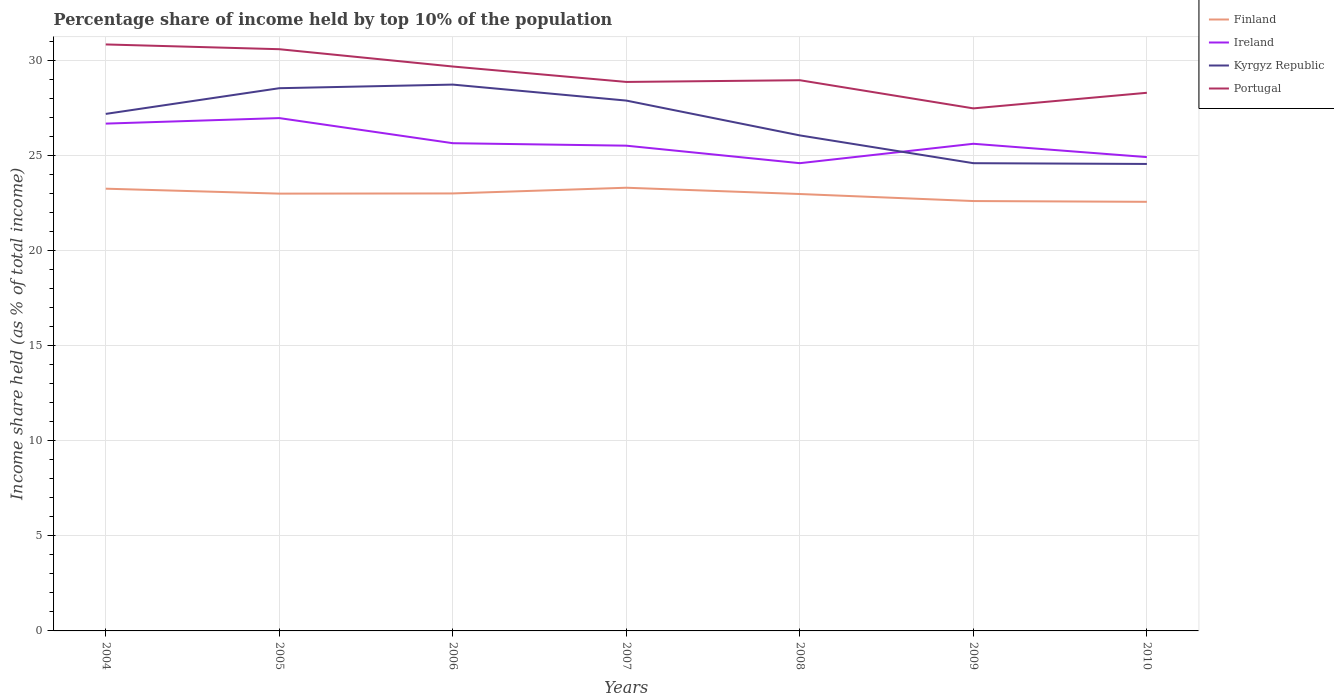Is the number of lines equal to the number of legend labels?
Your response must be concise. Yes. Across all years, what is the maximum percentage share of income held by top 10% of the population in Kyrgyz Republic?
Keep it short and to the point. 24.54. What is the total percentage share of income held by top 10% of the population in Kyrgyz Republic in the graph?
Offer a terse response. 2.63. What is the difference between the highest and the second highest percentage share of income held by top 10% of the population in Finland?
Provide a succinct answer. 0.74. What is the difference between the highest and the lowest percentage share of income held by top 10% of the population in Ireland?
Offer a terse response. 2. Is the percentage share of income held by top 10% of the population in Ireland strictly greater than the percentage share of income held by top 10% of the population in Portugal over the years?
Your response must be concise. Yes. How many lines are there?
Make the answer very short. 4. Are the values on the major ticks of Y-axis written in scientific E-notation?
Ensure brevity in your answer.  No. How are the legend labels stacked?
Give a very brief answer. Vertical. What is the title of the graph?
Your answer should be very brief. Percentage share of income held by top 10% of the population. Does "Cambodia" appear as one of the legend labels in the graph?
Provide a short and direct response. No. What is the label or title of the X-axis?
Ensure brevity in your answer.  Years. What is the label or title of the Y-axis?
Your answer should be very brief. Income share held (as % of total income). What is the Income share held (as % of total income) in Finland in 2004?
Give a very brief answer. 23.24. What is the Income share held (as % of total income) in Ireland in 2004?
Ensure brevity in your answer.  26.66. What is the Income share held (as % of total income) in Kyrgyz Republic in 2004?
Offer a terse response. 27.17. What is the Income share held (as % of total income) of Portugal in 2004?
Your answer should be compact. 30.82. What is the Income share held (as % of total income) of Finland in 2005?
Give a very brief answer. 22.98. What is the Income share held (as % of total income) in Ireland in 2005?
Keep it short and to the point. 26.95. What is the Income share held (as % of total income) in Kyrgyz Republic in 2005?
Keep it short and to the point. 28.52. What is the Income share held (as % of total income) in Portugal in 2005?
Keep it short and to the point. 30.57. What is the Income share held (as % of total income) of Finland in 2006?
Provide a short and direct response. 22.99. What is the Income share held (as % of total income) of Ireland in 2006?
Offer a terse response. 25.63. What is the Income share held (as % of total income) in Kyrgyz Republic in 2006?
Make the answer very short. 28.71. What is the Income share held (as % of total income) of Portugal in 2006?
Provide a succinct answer. 29.66. What is the Income share held (as % of total income) in Finland in 2007?
Provide a succinct answer. 23.29. What is the Income share held (as % of total income) in Ireland in 2007?
Provide a short and direct response. 25.5. What is the Income share held (as % of total income) of Kyrgyz Republic in 2007?
Provide a succinct answer. 27.87. What is the Income share held (as % of total income) in Portugal in 2007?
Your answer should be compact. 28.85. What is the Income share held (as % of total income) in Finland in 2008?
Offer a terse response. 22.96. What is the Income share held (as % of total income) of Ireland in 2008?
Your answer should be compact. 24.58. What is the Income share held (as % of total income) of Kyrgyz Republic in 2008?
Ensure brevity in your answer.  26.04. What is the Income share held (as % of total income) of Portugal in 2008?
Keep it short and to the point. 28.94. What is the Income share held (as % of total income) of Finland in 2009?
Make the answer very short. 22.59. What is the Income share held (as % of total income) in Ireland in 2009?
Keep it short and to the point. 25.6. What is the Income share held (as % of total income) of Kyrgyz Republic in 2009?
Make the answer very short. 24.58. What is the Income share held (as % of total income) in Portugal in 2009?
Ensure brevity in your answer.  27.46. What is the Income share held (as % of total income) of Finland in 2010?
Your answer should be very brief. 22.55. What is the Income share held (as % of total income) in Ireland in 2010?
Make the answer very short. 24.9. What is the Income share held (as % of total income) of Kyrgyz Republic in 2010?
Your answer should be very brief. 24.54. What is the Income share held (as % of total income) of Portugal in 2010?
Ensure brevity in your answer.  28.28. Across all years, what is the maximum Income share held (as % of total income) of Finland?
Provide a short and direct response. 23.29. Across all years, what is the maximum Income share held (as % of total income) in Ireland?
Offer a terse response. 26.95. Across all years, what is the maximum Income share held (as % of total income) in Kyrgyz Republic?
Your response must be concise. 28.71. Across all years, what is the maximum Income share held (as % of total income) of Portugal?
Your answer should be very brief. 30.82. Across all years, what is the minimum Income share held (as % of total income) in Finland?
Provide a succinct answer. 22.55. Across all years, what is the minimum Income share held (as % of total income) of Ireland?
Ensure brevity in your answer.  24.58. Across all years, what is the minimum Income share held (as % of total income) in Kyrgyz Republic?
Give a very brief answer. 24.54. Across all years, what is the minimum Income share held (as % of total income) in Portugal?
Your response must be concise. 27.46. What is the total Income share held (as % of total income) of Finland in the graph?
Ensure brevity in your answer.  160.6. What is the total Income share held (as % of total income) of Ireland in the graph?
Your answer should be compact. 179.82. What is the total Income share held (as % of total income) of Kyrgyz Republic in the graph?
Your response must be concise. 187.43. What is the total Income share held (as % of total income) in Portugal in the graph?
Ensure brevity in your answer.  204.58. What is the difference between the Income share held (as % of total income) in Finland in 2004 and that in 2005?
Provide a short and direct response. 0.26. What is the difference between the Income share held (as % of total income) of Ireland in 2004 and that in 2005?
Your response must be concise. -0.29. What is the difference between the Income share held (as % of total income) in Kyrgyz Republic in 2004 and that in 2005?
Give a very brief answer. -1.35. What is the difference between the Income share held (as % of total income) in Finland in 2004 and that in 2006?
Your response must be concise. 0.25. What is the difference between the Income share held (as % of total income) of Ireland in 2004 and that in 2006?
Provide a short and direct response. 1.03. What is the difference between the Income share held (as % of total income) of Kyrgyz Republic in 2004 and that in 2006?
Your answer should be compact. -1.54. What is the difference between the Income share held (as % of total income) of Portugal in 2004 and that in 2006?
Offer a very short reply. 1.16. What is the difference between the Income share held (as % of total income) of Ireland in 2004 and that in 2007?
Ensure brevity in your answer.  1.16. What is the difference between the Income share held (as % of total income) in Portugal in 2004 and that in 2007?
Give a very brief answer. 1.97. What is the difference between the Income share held (as % of total income) of Finland in 2004 and that in 2008?
Make the answer very short. 0.28. What is the difference between the Income share held (as % of total income) of Ireland in 2004 and that in 2008?
Keep it short and to the point. 2.08. What is the difference between the Income share held (as % of total income) of Kyrgyz Republic in 2004 and that in 2008?
Your answer should be compact. 1.13. What is the difference between the Income share held (as % of total income) of Portugal in 2004 and that in 2008?
Ensure brevity in your answer.  1.88. What is the difference between the Income share held (as % of total income) of Finland in 2004 and that in 2009?
Provide a short and direct response. 0.65. What is the difference between the Income share held (as % of total income) in Ireland in 2004 and that in 2009?
Give a very brief answer. 1.06. What is the difference between the Income share held (as % of total income) of Kyrgyz Republic in 2004 and that in 2009?
Offer a terse response. 2.59. What is the difference between the Income share held (as % of total income) in Portugal in 2004 and that in 2009?
Give a very brief answer. 3.36. What is the difference between the Income share held (as % of total income) of Finland in 2004 and that in 2010?
Make the answer very short. 0.69. What is the difference between the Income share held (as % of total income) of Ireland in 2004 and that in 2010?
Make the answer very short. 1.76. What is the difference between the Income share held (as % of total income) in Kyrgyz Republic in 2004 and that in 2010?
Your response must be concise. 2.63. What is the difference between the Income share held (as % of total income) of Portugal in 2004 and that in 2010?
Provide a short and direct response. 2.54. What is the difference between the Income share held (as % of total income) of Finland in 2005 and that in 2006?
Make the answer very short. -0.01. What is the difference between the Income share held (as % of total income) in Ireland in 2005 and that in 2006?
Offer a terse response. 1.32. What is the difference between the Income share held (as % of total income) in Kyrgyz Republic in 2005 and that in 2006?
Your response must be concise. -0.19. What is the difference between the Income share held (as % of total income) in Portugal in 2005 and that in 2006?
Your response must be concise. 0.91. What is the difference between the Income share held (as % of total income) of Finland in 2005 and that in 2007?
Offer a very short reply. -0.31. What is the difference between the Income share held (as % of total income) in Ireland in 2005 and that in 2007?
Make the answer very short. 1.45. What is the difference between the Income share held (as % of total income) in Kyrgyz Republic in 2005 and that in 2007?
Give a very brief answer. 0.65. What is the difference between the Income share held (as % of total income) in Portugal in 2005 and that in 2007?
Offer a terse response. 1.72. What is the difference between the Income share held (as % of total income) in Ireland in 2005 and that in 2008?
Your answer should be compact. 2.37. What is the difference between the Income share held (as % of total income) in Kyrgyz Republic in 2005 and that in 2008?
Offer a terse response. 2.48. What is the difference between the Income share held (as % of total income) in Portugal in 2005 and that in 2008?
Offer a terse response. 1.63. What is the difference between the Income share held (as % of total income) in Finland in 2005 and that in 2009?
Make the answer very short. 0.39. What is the difference between the Income share held (as % of total income) in Ireland in 2005 and that in 2009?
Ensure brevity in your answer.  1.35. What is the difference between the Income share held (as % of total income) of Kyrgyz Republic in 2005 and that in 2009?
Give a very brief answer. 3.94. What is the difference between the Income share held (as % of total income) of Portugal in 2005 and that in 2009?
Keep it short and to the point. 3.11. What is the difference between the Income share held (as % of total income) of Finland in 2005 and that in 2010?
Keep it short and to the point. 0.43. What is the difference between the Income share held (as % of total income) of Ireland in 2005 and that in 2010?
Offer a terse response. 2.05. What is the difference between the Income share held (as % of total income) in Kyrgyz Republic in 2005 and that in 2010?
Provide a succinct answer. 3.98. What is the difference between the Income share held (as % of total income) in Portugal in 2005 and that in 2010?
Offer a very short reply. 2.29. What is the difference between the Income share held (as % of total income) in Finland in 2006 and that in 2007?
Keep it short and to the point. -0.3. What is the difference between the Income share held (as % of total income) of Ireland in 2006 and that in 2007?
Ensure brevity in your answer.  0.13. What is the difference between the Income share held (as % of total income) of Kyrgyz Republic in 2006 and that in 2007?
Ensure brevity in your answer.  0.84. What is the difference between the Income share held (as % of total income) in Portugal in 2006 and that in 2007?
Make the answer very short. 0.81. What is the difference between the Income share held (as % of total income) in Finland in 2006 and that in 2008?
Provide a short and direct response. 0.03. What is the difference between the Income share held (as % of total income) in Kyrgyz Republic in 2006 and that in 2008?
Make the answer very short. 2.67. What is the difference between the Income share held (as % of total income) of Portugal in 2006 and that in 2008?
Your response must be concise. 0.72. What is the difference between the Income share held (as % of total income) of Finland in 2006 and that in 2009?
Provide a short and direct response. 0.4. What is the difference between the Income share held (as % of total income) of Kyrgyz Republic in 2006 and that in 2009?
Provide a short and direct response. 4.13. What is the difference between the Income share held (as % of total income) in Finland in 2006 and that in 2010?
Your response must be concise. 0.44. What is the difference between the Income share held (as % of total income) of Ireland in 2006 and that in 2010?
Provide a succinct answer. 0.73. What is the difference between the Income share held (as % of total income) of Kyrgyz Republic in 2006 and that in 2010?
Keep it short and to the point. 4.17. What is the difference between the Income share held (as % of total income) in Portugal in 2006 and that in 2010?
Offer a very short reply. 1.38. What is the difference between the Income share held (as % of total income) of Finland in 2007 and that in 2008?
Give a very brief answer. 0.33. What is the difference between the Income share held (as % of total income) in Ireland in 2007 and that in 2008?
Your answer should be compact. 0.92. What is the difference between the Income share held (as % of total income) of Kyrgyz Republic in 2007 and that in 2008?
Provide a succinct answer. 1.83. What is the difference between the Income share held (as % of total income) of Portugal in 2007 and that in 2008?
Give a very brief answer. -0.09. What is the difference between the Income share held (as % of total income) of Ireland in 2007 and that in 2009?
Offer a very short reply. -0.1. What is the difference between the Income share held (as % of total income) of Kyrgyz Republic in 2007 and that in 2009?
Your answer should be very brief. 3.29. What is the difference between the Income share held (as % of total income) in Portugal in 2007 and that in 2009?
Give a very brief answer. 1.39. What is the difference between the Income share held (as % of total income) in Finland in 2007 and that in 2010?
Your answer should be very brief. 0.74. What is the difference between the Income share held (as % of total income) of Ireland in 2007 and that in 2010?
Provide a succinct answer. 0.6. What is the difference between the Income share held (as % of total income) in Kyrgyz Republic in 2007 and that in 2010?
Give a very brief answer. 3.33. What is the difference between the Income share held (as % of total income) of Portugal in 2007 and that in 2010?
Give a very brief answer. 0.57. What is the difference between the Income share held (as % of total income) of Finland in 2008 and that in 2009?
Offer a terse response. 0.37. What is the difference between the Income share held (as % of total income) in Ireland in 2008 and that in 2009?
Your answer should be compact. -1.02. What is the difference between the Income share held (as % of total income) in Kyrgyz Republic in 2008 and that in 2009?
Your answer should be compact. 1.46. What is the difference between the Income share held (as % of total income) in Portugal in 2008 and that in 2009?
Ensure brevity in your answer.  1.48. What is the difference between the Income share held (as % of total income) of Finland in 2008 and that in 2010?
Make the answer very short. 0.41. What is the difference between the Income share held (as % of total income) of Ireland in 2008 and that in 2010?
Ensure brevity in your answer.  -0.32. What is the difference between the Income share held (as % of total income) in Kyrgyz Republic in 2008 and that in 2010?
Provide a short and direct response. 1.5. What is the difference between the Income share held (as % of total income) in Portugal in 2008 and that in 2010?
Your answer should be compact. 0.66. What is the difference between the Income share held (as % of total income) of Finland in 2009 and that in 2010?
Offer a very short reply. 0.04. What is the difference between the Income share held (as % of total income) of Ireland in 2009 and that in 2010?
Provide a short and direct response. 0.7. What is the difference between the Income share held (as % of total income) of Kyrgyz Republic in 2009 and that in 2010?
Make the answer very short. 0.04. What is the difference between the Income share held (as % of total income) in Portugal in 2009 and that in 2010?
Give a very brief answer. -0.82. What is the difference between the Income share held (as % of total income) of Finland in 2004 and the Income share held (as % of total income) of Ireland in 2005?
Your answer should be very brief. -3.71. What is the difference between the Income share held (as % of total income) in Finland in 2004 and the Income share held (as % of total income) in Kyrgyz Republic in 2005?
Keep it short and to the point. -5.28. What is the difference between the Income share held (as % of total income) in Finland in 2004 and the Income share held (as % of total income) in Portugal in 2005?
Provide a succinct answer. -7.33. What is the difference between the Income share held (as % of total income) in Ireland in 2004 and the Income share held (as % of total income) in Kyrgyz Republic in 2005?
Keep it short and to the point. -1.86. What is the difference between the Income share held (as % of total income) of Ireland in 2004 and the Income share held (as % of total income) of Portugal in 2005?
Your answer should be compact. -3.91. What is the difference between the Income share held (as % of total income) in Kyrgyz Republic in 2004 and the Income share held (as % of total income) in Portugal in 2005?
Your answer should be very brief. -3.4. What is the difference between the Income share held (as % of total income) in Finland in 2004 and the Income share held (as % of total income) in Ireland in 2006?
Offer a very short reply. -2.39. What is the difference between the Income share held (as % of total income) of Finland in 2004 and the Income share held (as % of total income) of Kyrgyz Republic in 2006?
Give a very brief answer. -5.47. What is the difference between the Income share held (as % of total income) in Finland in 2004 and the Income share held (as % of total income) in Portugal in 2006?
Give a very brief answer. -6.42. What is the difference between the Income share held (as % of total income) of Ireland in 2004 and the Income share held (as % of total income) of Kyrgyz Republic in 2006?
Your response must be concise. -2.05. What is the difference between the Income share held (as % of total income) of Ireland in 2004 and the Income share held (as % of total income) of Portugal in 2006?
Keep it short and to the point. -3. What is the difference between the Income share held (as % of total income) in Kyrgyz Republic in 2004 and the Income share held (as % of total income) in Portugal in 2006?
Ensure brevity in your answer.  -2.49. What is the difference between the Income share held (as % of total income) of Finland in 2004 and the Income share held (as % of total income) of Ireland in 2007?
Keep it short and to the point. -2.26. What is the difference between the Income share held (as % of total income) in Finland in 2004 and the Income share held (as % of total income) in Kyrgyz Republic in 2007?
Ensure brevity in your answer.  -4.63. What is the difference between the Income share held (as % of total income) in Finland in 2004 and the Income share held (as % of total income) in Portugal in 2007?
Your answer should be compact. -5.61. What is the difference between the Income share held (as % of total income) of Ireland in 2004 and the Income share held (as % of total income) of Kyrgyz Republic in 2007?
Give a very brief answer. -1.21. What is the difference between the Income share held (as % of total income) of Ireland in 2004 and the Income share held (as % of total income) of Portugal in 2007?
Offer a terse response. -2.19. What is the difference between the Income share held (as % of total income) in Kyrgyz Republic in 2004 and the Income share held (as % of total income) in Portugal in 2007?
Ensure brevity in your answer.  -1.68. What is the difference between the Income share held (as % of total income) in Finland in 2004 and the Income share held (as % of total income) in Ireland in 2008?
Your response must be concise. -1.34. What is the difference between the Income share held (as % of total income) in Finland in 2004 and the Income share held (as % of total income) in Kyrgyz Republic in 2008?
Your answer should be very brief. -2.8. What is the difference between the Income share held (as % of total income) in Finland in 2004 and the Income share held (as % of total income) in Portugal in 2008?
Offer a terse response. -5.7. What is the difference between the Income share held (as % of total income) in Ireland in 2004 and the Income share held (as % of total income) in Kyrgyz Republic in 2008?
Offer a very short reply. 0.62. What is the difference between the Income share held (as % of total income) of Ireland in 2004 and the Income share held (as % of total income) of Portugal in 2008?
Ensure brevity in your answer.  -2.28. What is the difference between the Income share held (as % of total income) of Kyrgyz Republic in 2004 and the Income share held (as % of total income) of Portugal in 2008?
Ensure brevity in your answer.  -1.77. What is the difference between the Income share held (as % of total income) in Finland in 2004 and the Income share held (as % of total income) in Ireland in 2009?
Your answer should be compact. -2.36. What is the difference between the Income share held (as % of total income) of Finland in 2004 and the Income share held (as % of total income) of Kyrgyz Republic in 2009?
Offer a terse response. -1.34. What is the difference between the Income share held (as % of total income) of Finland in 2004 and the Income share held (as % of total income) of Portugal in 2009?
Your response must be concise. -4.22. What is the difference between the Income share held (as % of total income) in Ireland in 2004 and the Income share held (as % of total income) in Kyrgyz Republic in 2009?
Offer a terse response. 2.08. What is the difference between the Income share held (as % of total income) of Kyrgyz Republic in 2004 and the Income share held (as % of total income) of Portugal in 2009?
Offer a terse response. -0.29. What is the difference between the Income share held (as % of total income) in Finland in 2004 and the Income share held (as % of total income) in Ireland in 2010?
Offer a very short reply. -1.66. What is the difference between the Income share held (as % of total income) in Finland in 2004 and the Income share held (as % of total income) in Kyrgyz Republic in 2010?
Provide a short and direct response. -1.3. What is the difference between the Income share held (as % of total income) in Finland in 2004 and the Income share held (as % of total income) in Portugal in 2010?
Give a very brief answer. -5.04. What is the difference between the Income share held (as % of total income) of Ireland in 2004 and the Income share held (as % of total income) of Kyrgyz Republic in 2010?
Provide a short and direct response. 2.12. What is the difference between the Income share held (as % of total income) of Ireland in 2004 and the Income share held (as % of total income) of Portugal in 2010?
Offer a terse response. -1.62. What is the difference between the Income share held (as % of total income) in Kyrgyz Republic in 2004 and the Income share held (as % of total income) in Portugal in 2010?
Ensure brevity in your answer.  -1.11. What is the difference between the Income share held (as % of total income) of Finland in 2005 and the Income share held (as % of total income) of Ireland in 2006?
Your response must be concise. -2.65. What is the difference between the Income share held (as % of total income) in Finland in 2005 and the Income share held (as % of total income) in Kyrgyz Republic in 2006?
Offer a very short reply. -5.73. What is the difference between the Income share held (as % of total income) of Finland in 2005 and the Income share held (as % of total income) of Portugal in 2006?
Your answer should be very brief. -6.68. What is the difference between the Income share held (as % of total income) of Ireland in 2005 and the Income share held (as % of total income) of Kyrgyz Republic in 2006?
Offer a very short reply. -1.76. What is the difference between the Income share held (as % of total income) of Ireland in 2005 and the Income share held (as % of total income) of Portugal in 2006?
Provide a short and direct response. -2.71. What is the difference between the Income share held (as % of total income) in Kyrgyz Republic in 2005 and the Income share held (as % of total income) in Portugal in 2006?
Provide a short and direct response. -1.14. What is the difference between the Income share held (as % of total income) of Finland in 2005 and the Income share held (as % of total income) of Ireland in 2007?
Give a very brief answer. -2.52. What is the difference between the Income share held (as % of total income) in Finland in 2005 and the Income share held (as % of total income) in Kyrgyz Republic in 2007?
Your answer should be compact. -4.89. What is the difference between the Income share held (as % of total income) in Finland in 2005 and the Income share held (as % of total income) in Portugal in 2007?
Give a very brief answer. -5.87. What is the difference between the Income share held (as % of total income) in Ireland in 2005 and the Income share held (as % of total income) in Kyrgyz Republic in 2007?
Your response must be concise. -0.92. What is the difference between the Income share held (as % of total income) of Ireland in 2005 and the Income share held (as % of total income) of Portugal in 2007?
Your answer should be compact. -1.9. What is the difference between the Income share held (as % of total income) in Kyrgyz Republic in 2005 and the Income share held (as % of total income) in Portugal in 2007?
Ensure brevity in your answer.  -0.33. What is the difference between the Income share held (as % of total income) of Finland in 2005 and the Income share held (as % of total income) of Ireland in 2008?
Give a very brief answer. -1.6. What is the difference between the Income share held (as % of total income) of Finland in 2005 and the Income share held (as % of total income) of Kyrgyz Republic in 2008?
Provide a succinct answer. -3.06. What is the difference between the Income share held (as % of total income) of Finland in 2005 and the Income share held (as % of total income) of Portugal in 2008?
Offer a very short reply. -5.96. What is the difference between the Income share held (as % of total income) of Ireland in 2005 and the Income share held (as % of total income) of Kyrgyz Republic in 2008?
Your response must be concise. 0.91. What is the difference between the Income share held (as % of total income) of Ireland in 2005 and the Income share held (as % of total income) of Portugal in 2008?
Provide a short and direct response. -1.99. What is the difference between the Income share held (as % of total income) of Kyrgyz Republic in 2005 and the Income share held (as % of total income) of Portugal in 2008?
Your answer should be compact. -0.42. What is the difference between the Income share held (as % of total income) in Finland in 2005 and the Income share held (as % of total income) in Ireland in 2009?
Give a very brief answer. -2.62. What is the difference between the Income share held (as % of total income) in Finland in 2005 and the Income share held (as % of total income) in Kyrgyz Republic in 2009?
Make the answer very short. -1.6. What is the difference between the Income share held (as % of total income) of Finland in 2005 and the Income share held (as % of total income) of Portugal in 2009?
Offer a very short reply. -4.48. What is the difference between the Income share held (as % of total income) in Ireland in 2005 and the Income share held (as % of total income) in Kyrgyz Republic in 2009?
Offer a very short reply. 2.37. What is the difference between the Income share held (as % of total income) in Ireland in 2005 and the Income share held (as % of total income) in Portugal in 2009?
Your answer should be compact. -0.51. What is the difference between the Income share held (as % of total income) of Kyrgyz Republic in 2005 and the Income share held (as % of total income) of Portugal in 2009?
Ensure brevity in your answer.  1.06. What is the difference between the Income share held (as % of total income) of Finland in 2005 and the Income share held (as % of total income) of Ireland in 2010?
Your answer should be very brief. -1.92. What is the difference between the Income share held (as % of total income) of Finland in 2005 and the Income share held (as % of total income) of Kyrgyz Republic in 2010?
Your response must be concise. -1.56. What is the difference between the Income share held (as % of total income) of Ireland in 2005 and the Income share held (as % of total income) of Kyrgyz Republic in 2010?
Offer a very short reply. 2.41. What is the difference between the Income share held (as % of total income) of Ireland in 2005 and the Income share held (as % of total income) of Portugal in 2010?
Your answer should be very brief. -1.33. What is the difference between the Income share held (as % of total income) in Kyrgyz Republic in 2005 and the Income share held (as % of total income) in Portugal in 2010?
Offer a terse response. 0.24. What is the difference between the Income share held (as % of total income) of Finland in 2006 and the Income share held (as % of total income) of Ireland in 2007?
Make the answer very short. -2.51. What is the difference between the Income share held (as % of total income) of Finland in 2006 and the Income share held (as % of total income) of Kyrgyz Republic in 2007?
Make the answer very short. -4.88. What is the difference between the Income share held (as % of total income) in Finland in 2006 and the Income share held (as % of total income) in Portugal in 2007?
Keep it short and to the point. -5.86. What is the difference between the Income share held (as % of total income) in Ireland in 2006 and the Income share held (as % of total income) in Kyrgyz Republic in 2007?
Make the answer very short. -2.24. What is the difference between the Income share held (as % of total income) in Ireland in 2006 and the Income share held (as % of total income) in Portugal in 2007?
Your response must be concise. -3.22. What is the difference between the Income share held (as % of total income) in Kyrgyz Republic in 2006 and the Income share held (as % of total income) in Portugal in 2007?
Provide a succinct answer. -0.14. What is the difference between the Income share held (as % of total income) in Finland in 2006 and the Income share held (as % of total income) in Ireland in 2008?
Make the answer very short. -1.59. What is the difference between the Income share held (as % of total income) of Finland in 2006 and the Income share held (as % of total income) of Kyrgyz Republic in 2008?
Provide a succinct answer. -3.05. What is the difference between the Income share held (as % of total income) of Finland in 2006 and the Income share held (as % of total income) of Portugal in 2008?
Make the answer very short. -5.95. What is the difference between the Income share held (as % of total income) of Ireland in 2006 and the Income share held (as % of total income) of Kyrgyz Republic in 2008?
Offer a terse response. -0.41. What is the difference between the Income share held (as % of total income) of Ireland in 2006 and the Income share held (as % of total income) of Portugal in 2008?
Your answer should be compact. -3.31. What is the difference between the Income share held (as % of total income) in Kyrgyz Republic in 2006 and the Income share held (as % of total income) in Portugal in 2008?
Offer a terse response. -0.23. What is the difference between the Income share held (as % of total income) in Finland in 2006 and the Income share held (as % of total income) in Ireland in 2009?
Ensure brevity in your answer.  -2.61. What is the difference between the Income share held (as % of total income) of Finland in 2006 and the Income share held (as % of total income) of Kyrgyz Republic in 2009?
Make the answer very short. -1.59. What is the difference between the Income share held (as % of total income) in Finland in 2006 and the Income share held (as % of total income) in Portugal in 2009?
Your answer should be compact. -4.47. What is the difference between the Income share held (as % of total income) in Ireland in 2006 and the Income share held (as % of total income) in Kyrgyz Republic in 2009?
Offer a terse response. 1.05. What is the difference between the Income share held (as % of total income) of Ireland in 2006 and the Income share held (as % of total income) of Portugal in 2009?
Offer a terse response. -1.83. What is the difference between the Income share held (as % of total income) of Finland in 2006 and the Income share held (as % of total income) of Ireland in 2010?
Provide a succinct answer. -1.91. What is the difference between the Income share held (as % of total income) in Finland in 2006 and the Income share held (as % of total income) in Kyrgyz Republic in 2010?
Your answer should be compact. -1.55. What is the difference between the Income share held (as % of total income) in Finland in 2006 and the Income share held (as % of total income) in Portugal in 2010?
Provide a succinct answer. -5.29. What is the difference between the Income share held (as % of total income) in Ireland in 2006 and the Income share held (as % of total income) in Kyrgyz Republic in 2010?
Provide a succinct answer. 1.09. What is the difference between the Income share held (as % of total income) in Ireland in 2006 and the Income share held (as % of total income) in Portugal in 2010?
Give a very brief answer. -2.65. What is the difference between the Income share held (as % of total income) of Kyrgyz Republic in 2006 and the Income share held (as % of total income) of Portugal in 2010?
Ensure brevity in your answer.  0.43. What is the difference between the Income share held (as % of total income) in Finland in 2007 and the Income share held (as % of total income) in Ireland in 2008?
Ensure brevity in your answer.  -1.29. What is the difference between the Income share held (as % of total income) of Finland in 2007 and the Income share held (as % of total income) of Kyrgyz Republic in 2008?
Keep it short and to the point. -2.75. What is the difference between the Income share held (as % of total income) of Finland in 2007 and the Income share held (as % of total income) of Portugal in 2008?
Provide a short and direct response. -5.65. What is the difference between the Income share held (as % of total income) of Ireland in 2007 and the Income share held (as % of total income) of Kyrgyz Republic in 2008?
Your answer should be compact. -0.54. What is the difference between the Income share held (as % of total income) in Ireland in 2007 and the Income share held (as % of total income) in Portugal in 2008?
Ensure brevity in your answer.  -3.44. What is the difference between the Income share held (as % of total income) of Kyrgyz Republic in 2007 and the Income share held (as % of total income) of Portugal in 2008?
Offer a very short reply. -1.07. What is the difference between the Income share held (as % of total income) in Finland in 2007 and the Income share held (as % of total income) in Ireland in 2009?
Provide a succinct answer. -2.31. What is the difference between the Income share held (as % of total income) in Finland in 2007 and the Income share held (as % of total income) in Kyrgyz Republic in 2009?
Provide a short and direct response. -1.29. What is the difference between the Income share held (as % of total income) in Finland in 2007 and the Income share held (as % of total income) in Portugal in 2009?
Your answer should be very brief. -4.17. What is the difference between the Income share held (as % of total income) of Ireland in 2007 and the Income share held (as % of total income) of Kyrgyz Republic in 2009?
Your answer should be compact. 0.92. What is the difference between the Income share held (as % of total income) in Ireland in 2007 and the Income share held (as % of total income) in Portugal in 2009?
Give a very brief answer. -1.96. What is the difference between the Income share held (as % of total income) in Kyrgyz Republic in 2007 and the Income share held (as % of total income) in Portugal in 2009?
Ensure brevity in your answer.  0.41. What is the difference between the Income share held (as % of total income) of Finland in 2007 and the Income share held (as % of total income) of Ireland in 2010?
Your answer should be compact. -1.61. What is the difference between the Income share held (as % of total income) in Finland in 2007 and the Income share held (as % of total income) in Kyrgyz Republic in 2010?
Keep it short and to the point. -1.25. What is the difference between the Income share held (as % of total income) in Finland in 2007 and the Income share held (as % of total income) in Portugal in 2010?
Make the answer very short. -4.99. What is the difference between the Income share held (as % of total income) in Ireland in 2007 and the Income share held (as % of total income) in Kyrgyz Republic in 2010?
Provide a short and direct response. 0.96. What is the difference between the Income share held (as % of total income) in Ireland in 2007 and the Income share held (as % of total income) in Portugal in 2010?
Offer a very short reply. -2.78. What is the difference between the Income share held (as % of total income) in Kyrgyz Republic in 2007 and the Income share held (as % of total income) in Portugal in 2010?
Your answer should be compact. -0.41. What is the difference between the Income share held (as % of total income) in Finland in 2008 and the Income share held (as % of total income) in Ireland in 2009?
Keep it short and to the point. -2.64. What is the difference between the Income share held (as % of total income) in Finland in 2008 and the Income share held (as % of total income) in Kyrgyz Republic in 2009?
Give a very brief answer. -1.62. What is the difference between the Income share held (as % of total income) of Finland in 2008 and the Income share held (as % of total income) of Portugal in 2009?
Make the answer very short. -4.5. What is the difference between the Income share held (as % of total income) in Ireland in 2008 and the Income share held (as % of total income) in Kyrgyz Republic in 2009?
Provide a short and direct response. 0. What is the difference between the Income share held (as % of total income) of Ireland in 2008 and the Income share held (as % of total income) of Portugal in 2009?
Keep it short and to the point. -2.88. What is the difference between the Income share held (as % of total income) in Kyrgyz Republic in 2008 and the Income share held (as % of total income) in Portugal in 2009?
Offer a terse response. -1.42. What is the difference between the Income share held (as % of total income) of Finland in 2008 and the Income share held (as % of total income) of Ireland in 2010?
Offer a very short reply. -1.94. What is the difference between the Income share held (as % of total income) in Finland in 2008 and the Income share held (as % of total income) in Kyrgyz Republic in 2010?
Make the answer very short. -1.58. What is the difference between the Income share held (as % of total income) in Finland in 2008 and the Income share held (as % of total income) in Portugal in 2010?
Your answer should be compact. -5.32. What is the difference between the Income share held (as % of total income) of Ireland in 2008 and the Income share held (as % of total income) of Kyrgyz Republic in 2010?
Offer a terse response. 0.04. What is the difference between the Income share held (as % of total income) in Ireland in 2008 and the Income share held (as % of total income) in Portugal in 2010?
Provide a short and direct response. -3.7. What is the difference between the Income share held (as % of total income) of Kyrgyz Republic in 2008 and the Income share held (as % of total income) of Portugal in 2010?
Give a very brief answer. -2.24. What is the difference between the Income share held (as % of total income) of Finland in 2009 and the Income share held (as % of total income) of Ireland in 2010?
Keep it short and to the point. -2.31. What is the difference between the Income share held (as % of total income) in Finland in 2009 and the Income share held (as % of total income) in Kyrgyz Republic in 2010?
Your answer should be very brief. -1.95. What is the difference between the Income share held (as % of total income) in Finland in 2009 and the Income share held (as % of total income) in Portugal in 2010?
Provide a short and direct response. -5.69. What is the difference between the Income share held (as % of total income) in Ireland in 2009 and the Income share held (as % of total income) in Kyrgyz Republic in 2010?
Provide a short and direct response. 1.06. What is the difference between the Income share held (as % of total income) in Ireland in 2009 and the Income share held (as % of total income) in Portugal in 2010?
Give a very brief answer. -2.68. What is the difference between the Income share held (as % of total income) in Kyrgyz Republic in 2009 and the Income share held (as % of total income) in Portugal in 2010?
Provide a succinct answer. -3.7. What is the average Income share held (as % of total income) of Finland per year?
Ensure brevity in your answer.  22.94. What is the average Income share held (as % of total income) of Ireland per year?
Your answer should be very brief. 25.69. What is the average Income share held (as % of total income) of Kyrgyz Republic per year?
Offer a terse response. 26.78. What is the average Income share held (as % of total income) in Portugal per year?
Provide a succinct answer. 29.23. In the year 2004, what is the difference between the Income share held (as % of total income) of Finland and Income share held (as % of total income) of Ireland?
Ensure brevity in your answer.  -3.42. In the year 2004, what is the difference between the Income share held (as % of total income) of Finland and Income share held (as % of total income) of Kyrgyz Republic?
Ensure brevity in your answer.  -3.93. In the year 2004, what is the difference between the Income share held (as % of total income) of Finland and Income share held (as % of total income) of Portugal?
Provide a succinct answer. -7.58. In the year 2004, what is the difference between the Income share held (as % of total income) in Ireland and Income share held (as % of total income) in Kyrgyz Republic?
Offer a very short reply. -0.51. In the year 2004, what is the difference between the Income share held (as % of total income) of Ireland and Income share held (as % of total income) of Portugal?
Keep it short and to the point. -4.16. In the year 2004, what is the difference between the Income share held (as % of total income) of Kyrgyz Republic and Income share held (as % of total income) of Portugal?
Offer a very short reply. -3.65. In the year 2005, what is the difference between the Income share held (as % of total income) in Finland and Income share held (as % of total income) in Ireland?
Offer a very short reply. -3.97. In the year 2005, what is the difference between the Income share held (as % of total income) of Finland and Income share held (as % of total income) of Kyrgyz Republic?
Your answer should be compact. -5.54. In the year 2005, what is the difference between the Income share held (as % of total income) in Finland and Income share held (as % of total income) in Portugal?
Your answer should be very brief. -7.59. In the year 2005, what is the difference between the Income share held (as % of total income) in Ireland and Income share held (as % of total income) in Kyrgyz Republic?
Your answer should be compact. -1.57. In the year 2005, what is the difference between the Income share held (as % of total income) of Ireland and Income share held (as % of total income) of Portugal?
Offer a terse response. -3.62. In the year 2005, what is the difference between the Income share held (as % of total income) of Kyrgyz Republic and Income share held (as % of total income) of Portugal?
Offer a terse response. -2.05. In the year 2006, what is the difference between the Income share held (as % of total income) in Finland and Income share held (as % of total income) in Ireland?
Provide a succinct answer. -2.64. In the year 2006, what is the difference between the Income share held (as % of total income) in Finland and Income share held (as % of total income) in Kyrgyz Republic?
Ensure brevity in your answer.  -5.72. In the year 2006, what is the difference between the Income share held (as % of total income) in Finland and Income share held (as % of total income) in Portugal?
Offer a terse response. -6.67. In the year 2006, what is the difference between the Income share held (as % of total income) in Ireland and Income share held (as % of total income) in Kyrgyz Republic?
Give a very brief answer. -3.08. In the year 2006, what is the difference between the Income share held (as % of total income) of Ireland and Income share held (as % of total income) of Portugal?
Provide a short and direct response. -4.03. In the year 2006, what is the difference between the Income share held (as % of total income) of Kyrgyz Republic and Income share held (as % of total income) of Portugal?
Your response must be concise. -0.95. In the year 2007, what is the difference between the Income share held (as % of total income) in Finland and Income share held (as % of total income) in Ireland?
Provide a short and direct response. -2.21. In the year 2007, what is the difference between the Income share held (as % of total income) in Finland and Income share held (as % of total income) in Kyrgyz Republic?
Offer a terse response. -4.58. In the year 2007, what is the difference between the Income share held (as % of total income) of Finland and Income share held (as % of total income) of Portugal?
Offer a very short reply. -5.56. In the year 2007, what is the difference between the Income share held (as % of total income) of Ireland and Income share held (as % of total income) of Kyrgyz Republic?
Offer a terse response. -2.37. In the year 2007, what is the difference between the Income share held (as % of total income) in Ireland and Income share held (as % of total income) in Portugal?
Give a very brief answer. -3.35. In the year 2007, what is the difference between the Income share held (as % of total income) of Kyrgyz Republic and Income share held (as % of total income) of Portugal?
Your answer should be compact. -0.98. In the year 2008, what is the difference between the Income share held (as % of total income) in Finland and Income share held (as % of total income) in Ireland?
Provide a short and direct response. -1.62. In the year 2008, what is the difference between the Income share held (as % of total income) in Finland and Income share held (as % of total income) in Kyrgyz Republic?
Your answer should be very brief. -3.08. In the year 2008, what is the difference between the Income share held (as % of total income) of Finland and Income share held (as % of total income) of Portugal?
Give a very brief answer. -5.98. In the year 2008, what is the difference between the Income share held (as % of total income) in Ireland and Income share held (as % of total income) in Kyrgyz Republic?
Provide a succinct answer. -1.46. In the year 2008, what is the difference between the Income share held (as % of total income) in Ireland and Income share held (as % of total income) in Portugal?
Ensure brevity in your answer.  -4.36. In the year 2008, what is the difference between the Income share held (as % of total income) in Kyrgyz Republic and Income share held (as % of total income) in Portugal?
Give a very brief answer. -2.9. In the year 2009, what is the difference between the Income share held (as % of total income) of Finland and Income share held (as % of total income) of Ireland?
Offer a very short reply. -3.01. In the year 2009, what is the difference between the Income share held (as % of total income) in Finland and Income share held (as % of total income) in Kyrgyz Republic?
Offer a very short reply. -1.99. In the year 2009, what is the difference between the Income share held (as % of total income) in Finland and Income share held (as % of total income) in Portugal?
Make the answer very short. -4.87. In the year 2009, what is the difference between the Income share held (as % of total income) in Ireland and Income share held (as % of total income) in Kyrgyz Republic?
Provide a short and direct response. 1.02. In the year 2009, what is the difference between the Income share held (as % of total income) of Ireland and Income share held (as % of total income) of Portugal?
Keep it short and to the point. -1.86. In the year 2009, what is the difference between the Income share held (as % of total income) in Kyrgyz Republic and Income share held (as % of total income) in Portugal?
Ensure brevity in your answer.  -2.88. In the year 2010, what is the difference between the Income share held (as % of total income) in Finland and Income share held (as % of total income) in Ireland?
Keep it short and to the point. -2.35. In the year 2010, what is the difference between the Income share held (as % of total income) in Finland and Income share held (as % of total income) in Kyrgyz Republic?
Provide a short and direct response. -1.99. In the year 2010, what is the difference between the Income share held (as % of total income) of Finland and Income share held (as % of total income) of Portugal?
Your response must be concise. -5.73. In the year 2010, what is the difference between the Income share held (as % of total income) of Ireland and Income share held (as % of total income) of Kyrgyz Republic?
Provide a succinct answer. 0.36. In the year 2010, what is the difference between the Income share held (as % of total income) of Ireland and Income share held (as % of total income) of Portugal?
Your response must be concise. -3.38. In the year 2010, what is the difference between the Income share held (as % of total income) of Kyrgyz Republic and Income share held (as % of total income) of Portugal?
Your answer should be compact. -3.74. What is the ratio of the Income share held (as % of total income) in Finland in 2004 to that in 2005?
Provide a succinct answer. 1.01. What is the ratio of the Income share held (as % of total income) in Ireland in 2004 to that in 2005?
Your response must be concise. 0.99. What is the ratio of the Income share held (as % of total income) of Kyrgyz Republic in 2004 to that in 2005?
Ensure brevity in your answer.  0.95. What is the ratio of the Income share held (as % of total income) of Portugal in 2004 to that in 2005?
Offer a very short reply. 1.01. What is the ratio of the Income share held (as % of total income) in Finland in 2004 to that in 2006?
Your answer should be very brief. 1.01. What is the ratio of the Income share held (as % of total income) in Ireland in 2004 to that in 2006?
Your answer should be compact. 1.04. What is the ratio of the Income share held (as % of total income) in Kyrgyz Republic in 2004 to that in 2006?
Offer a terse response. 0.95. What is the ratio of the Income share held (as % of total income) in Portugal in 2004 to that in 2006?
Ensure brevity in your answer.  1.04. What is the ratio of the Income share held (as % of total income) in Finland in 2004 to that in 2007?
Make the answer very short. 1. What is the ratio of the Income share held (as % of total income) of Ireland in 2004 to that in 2007?
Keep it short and to the point. 1.05. What is the ratio of the Income share held (as % of total income) of Kyrgyz Republic in 2004 to that in 2007?
Ensure brevity in your answer.  0.97. What is the ratio of the Income share held (as % of total income) in Portugal in 2004 to that in 2007?
Offer a very short reply. 1.07. What is the ratio of the Income share held (as % of total income) in Finland in 2004 to that in 2008?
Ensure brevity in your answer.  1.01. What is the ratio of the Income share held (as % of total income) of Ireland in 2004 to that in 2008?
Ensure brevity in your answer.  1.08. What is the ratio of the Income share held (as % of total income) in Kyrgyz Republic in 2004 to that in 2008?
Keep it short and to the point. 1.04. What is the ratio of the Income share held (as % of total income) in Portugal in 2004 to that in 2008?
Your answer should be compact. 1.06. What is the ratio of the Income share held (as % of total income) of Finland in 2004 to that in 2009?
Ensure brevity in your answer.  1.03. What is the ratio of the Income share held (as % of total income) in Ireland in 2004 to that in 2009?
Offer a terse response. 1.04. What is the ratio of the Income share held (as % of total income) in Kyrgyz Republic in 2004 to that in 2009?
Give a very brief answer. 1.11. What is the ratio of the Income share held (as % of total income) in Portugal in 2004 to that in 2009?
Give a very brief answer. 1.12. What is the ratio of the Income share held (as % of total income) of Finland in 2004 to that in 2010?
Your answer should be compact. 1.03. What is the ratio of the Income share held (as % of total income) in Ireland in 2004 to that in 2010?
Your answer should be compact. 1.07. What is the ratio of the Income share held (as % of total income) of Kyrgyz Republic in 2004 to that in 2010?
Your answer should be very brief. 1.11. What is the ratio of the Income share held (as % of total income) of Portugal in 2004 to that in 2010?
Offer a very short reply. 1.09. What is the ratio of the Income share held (as % of total income) of Ireland in 2005 to that in 2006?
Give a very brief answer. 1.05. What is the ratio of the Income share held (as % of total income) of Kyrgyz Republic in 2005 to that in 2006?
Your answer should be very brief. 0.99. What is the ratio of the Income share held (as % of total income) of Portugal in 2005 to that in 2006?
Your answer should be compact. 1.03. What is the ratio of the Income share held (as % of total income) in Finland in 2005 to that in 2007?
Your answer should be compact. 0.99. What is the ratio of the Income share held (as % of total income) of Ireland in 2005 to that in 2007?
Keep it short and to the point. 1.06. What is the ratio of the Income share held (as % of total income) of Kyrgyz Republic in 2005 to that in 2007?
Your answer should be compact. 1.02. What is the ratio of the Income share held (as % of total income) of Portugal in 2005 to that in 2007?
Make the answer very short. 1.06. What is the ratio of the Income share held (as % of total income) of Ireland in 2005 to that in 2008?
Make the answer very short. 1.1. What is the ratio of the Income share held (as % of total income) of Kyrgyz Republic in 2005 to that in 2008?
Provide a succinct answer. 1.1. What is the ratio of the Income share held (as % of total income) of Portugal in 2005 to that in 2008?
Give a very brief answer. 1.06. What is the ratio of the Income share held (as % of total income) in Finland in 2005 to that in 2009?
Give a very brief answer. 1.02. What is the ratio of the Income share held (as % of total income) of Ireland in 2005 to that in 2009?
Provide a short and direct response. 1.05. What is the ratio of the Income share held (as % of total income) in Kyrgyz Republic in 2005 to that in 2009?
Your response must be concise. 1.16. What is the ratio of the Income share held (as % of total income) in Portugal in 2005 to that in 2009?
Offer a terse response. 1.11. What is the ratio of the Income share held (as % of total income) in Finland in 2005 to that in 2010?
Your answer should be very brief. 1.02. What is the ratio of the Income share held (as % of total income) in Ireland in 2005 to that in 2010?
Make the answer very short. 1.08. What is the ratio of the Income share held (as % of total income) of Kyrgyz Republic in 2005 to that in 2010?
Keep it short and to the point. 1.16. What is the ratio of the Income share held (as % of total income) in Portugal in 2005 to that in 2010?
Provide a short and direct response. 1.08. What is the ratio of the Income share held (as % of total income) in Finland in 2006 to that in 2007?
Your answer should be compact. 0.99. What is the ratio of the Income share held (as % of total income) in Kyrgyz Republic in 2006 to that in 2007?
Offer a very short reply. 1.03. What is the ratio of the Income share held (as % of total income) of Portugal in 2006 to that in 2007?
Your answer should be very brief. 1.03. What is the ratio of the Income share held (as % of total income) in Finland in 2006 to that in 2008?
Your response must be concise. 1. What is the ratio of the Income share held (as % of total income) of Ireland in 2006 to that in 2008?
Provide a succinct answer. 1.04. What is the ratio of the Income share held (as % of total income) in Kyrgyz Republic in 2006 to that in 2008?
Make the answer very short. 1.1. What is the ratio of the Income share held (as % of total income) of Portugal in 2006 to that in 2008?
Give a very brief answer. 1.02. What is the ratio of the Income share held (as % of total income) of Finland in 2006 to that in 2009?
Keep it short and to the point. 1.02. What is the ratio of the Income share held (as % of total income) in Ireland in 2006 to that in 2009?
Your answer should be compact. 1. What is the ratio of the Income share held (as % of total income) in Kyrgyz Republic in 2006 to that in 2009?
Give a very brief answer. 1.17. What is the ratio of the Income share held (as % of total income) in Portugal in 2006 to that in 2009?
Your answer should be compact. 1.08. What is the ratio of the Income share held (as % of total income) in Finland in 2006 to that in 2010?
Offer a very short reply. 1.02. What is the ratio of the Income share held (as % of total income) in Ireland in 2006 to that in 2010?
Your answer should be very brief. 1.03. What is the ratio of the Income share held (as % of total income) of Kyrgyz Republic in 2006 to that in 2010?
Give a very brief answer. 1.17. What is the ratio of the Income share held (as % of total income) of Portugal in 2006 to that in 2010?
Offer a terse response. 1.05. What is the ratio of the Income share held (as % of total income) in Finland in 2007 to that in 2008?
Give a very brief answer. 1.01. What is the ratio of the Income share held (as % of total income) of Ireland in 2007 to that in 2008?
Keep it short and to the point. 1.04. What is the ratio of the Income share held (as % of total income) in Kyrgyz Republic in 2007 to that in 2008?
Offer a terse response. 1.07. What is the ratio of the Income share held (as % of total income) in Finland in 2007 to that in 2009?
Give a very brief answer. 1.03. What is the ratio of the Income share held (as % of total income) of Kyrgyz Republic in 2007 to that in 2009?
Make the answer very short. 1.13. What is the ratio of the Income share held (as % of total income) in Portugal in 2007 to that in 2009?
Ensure brevity in your answer.  1.05. What is the ratio of the Income share held (as % of total income) in Finland in 2007 to that in 2010?
Provide a succinct answer. 1.03. What is the ratio of the Income share held (as % of total income) in Ireland in 2007 to that in 2010?
Offer a terse response. 1.02. What is the ratio of the Income share held (as % of total income) of Kyrgyz Republic in 2007 to that in 2010?
Your response must be concise. 1.14. What is the ratio of the Income share held (as % of total income) of Portugal in 2007 to that in 2010?
Provide a succinct answer. 1.02. What is the ratio of the Income share held (as % of total income) of Finland in 2008 to that in 2009?
Provide a short and direct response. 1.02. What is the ratio of the Income share held (as % of total income) in Ireland in 2008 to that in 2009?
Provide a succinct answer. 0.96. What is the ratio of the Income share held (as % of total income) in Kyrgyz Republic in 2008 to that in 2009?
Your answer should be very brief. 1.06. What is the ratio of the Income share held (as % of total income) of Portugal in 2008 to that in 2009?
Your answer should be compact. 1.05. What is the ratio of the Income share held (as % of total income) of Finland in 2008 to that in 2010?
Your answer should be compact. 1.02. What is the ratio of the Income share held (as % of total income) of Ireland in 2008 to that in 2010?
Offer a very short reply. 0.99. What is the ratio of the Income share held (as % of total income) in Kyrgyz Republic in 2008 to that in 2010?
Your response must be concise. 1.06. What is the ratio of the Income share held (as % of total income) in Portugal in 2008 to that in 2010?
Offer a very short reply. 1.02. What is the ratio of the Income share held (as % of total income) in Ireland in 2009 to that in 2010?
Ensure brevity in your answer.  1.03. What is the difference between the highest and the second highest Income share held (as % of total income) of Finland?
Give a very brief answer. 0.05. What is the difference between the highest and the second highest Income share held (as % of total income) in Ireland?
Offer a very short reply. 0.29. What is the difference between the highest and the second highest Income share held (as % of total income) of Kyrgyz Republic?
Your answer should be very brief. 0.19. What is the difference between the highest and the lowest Income share held (as % of total income) of Finland?
Your response must be concise. 0.74. What is the difference between the highest and the lowest Income share held (as % of total income) of Ireland?
Make the answer very short. 2.37. What is the difference between the highest and the lowest Income share held (as % of total income) in Kyrgyz Republic?
Provide a short and direct response. 4.17. What is the difference between the highest and the lowest Income share held (as % of total income) of Portugal?
Offer a terse response. 3.36. 